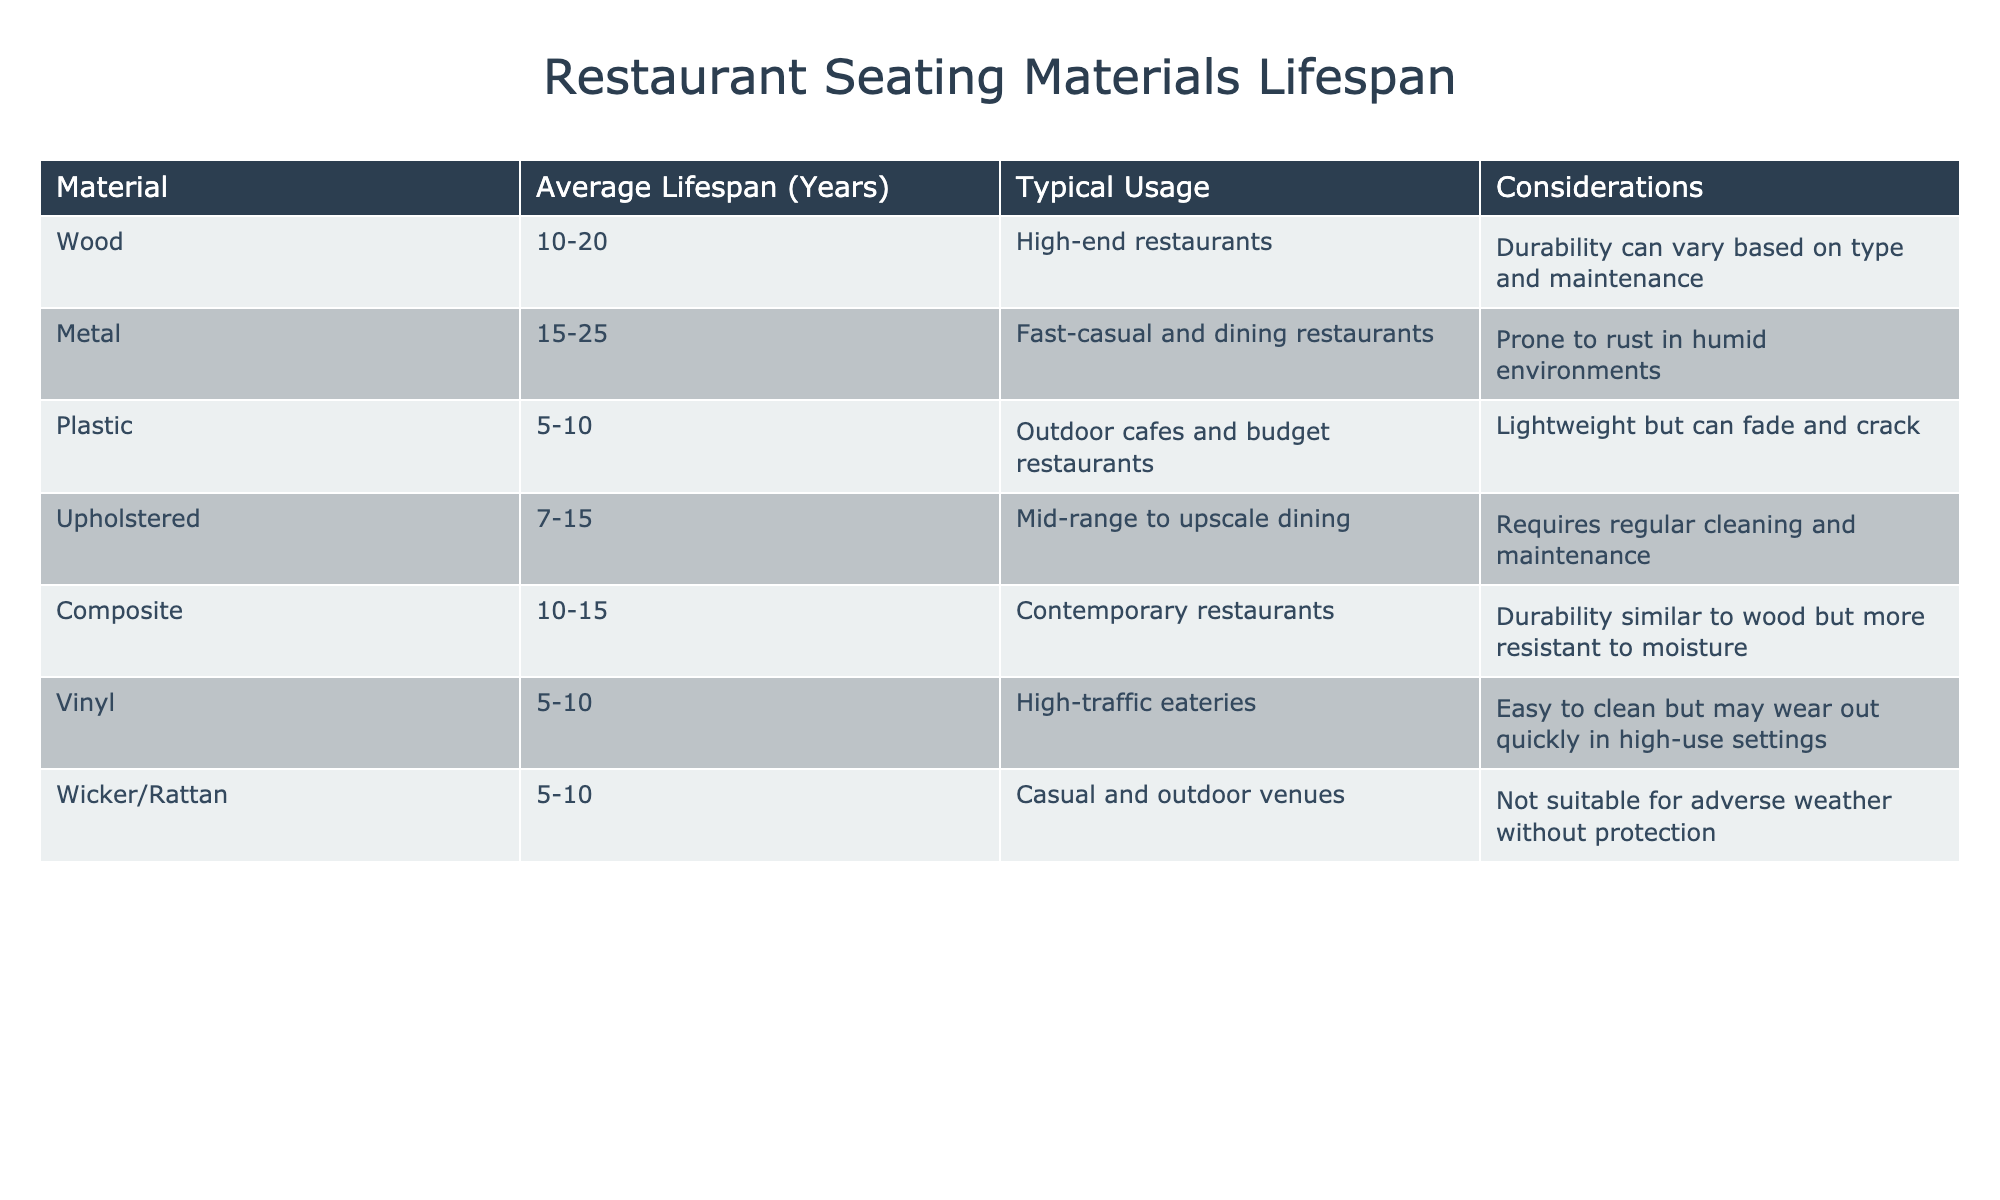What is the average lifespan of plastic seating? Referring to the table, plastic seating has an average lifespan ranging from 5 to 10 years.
Answer: 5-10 years Which material has the longest average lifespan? The material with the longest average lifespan is metal, with a range of 15 to 25 years.
Answer: Metal Is it true that upholstered seating requires regular cleaning? According to the table, upholstered seating indeed requires regular cleaning and maintenance.
Answer: Yes What is the difference in average lifespan between wood and vinyl seating? Wood has an average lifespan of 10 to 20 years, while vinyl lasts 5 to 10 years. The difference in their maximum lifespans is 20 - 10 = 10 years.
Answer: 10 years For which type of venues is wicker/rattan seating suitable? The table indicates that wicker/rattan seating is suitable for casual and outdoor venues.
Answer: Casual and outdoor venues What materials have a lifespan of 10 years or less? Referring to the table, plastic, vinyl, and wicker/rattan all have a maximum average lifespan of 10 years or less.
Answer: Plastic, vinyl, wicker/rattan What is the overall average lifespan for all materials listed? To find the overall average, we can take the midpoints of the ranges provided: ((15 + 10)/2 + (20 + 15)/2 + (10 + 5)/2 + (15 + 7)/2 + (12.5 + 10)/2 + (7.5 + 5)/2 + (7.5 + 5)/2) / 7 = 10.36 years (rounded).
Answer: 10.36 years Is it advisable to use metal seating in humid environments? The table states that metal is prone to rust in humid environments, which suggests it is not advisable.
Answer: No Which materials are recommended for high-traffic eateries? The table indicates that vinyl is recommended for high-traffic eateries due to its easy cleaning properties.
Answer: Vinyl 